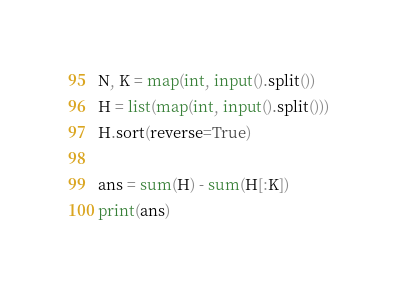Convert code to text. <code><loc_0><loc_0><loc_500><loc_500><_Python_>N, K = map(int, input().split())
H = list(map(int, input().split()))
H.sort(reverse=True)

ans = sum(H) - sum(H[:K])
print(ans)</code> 